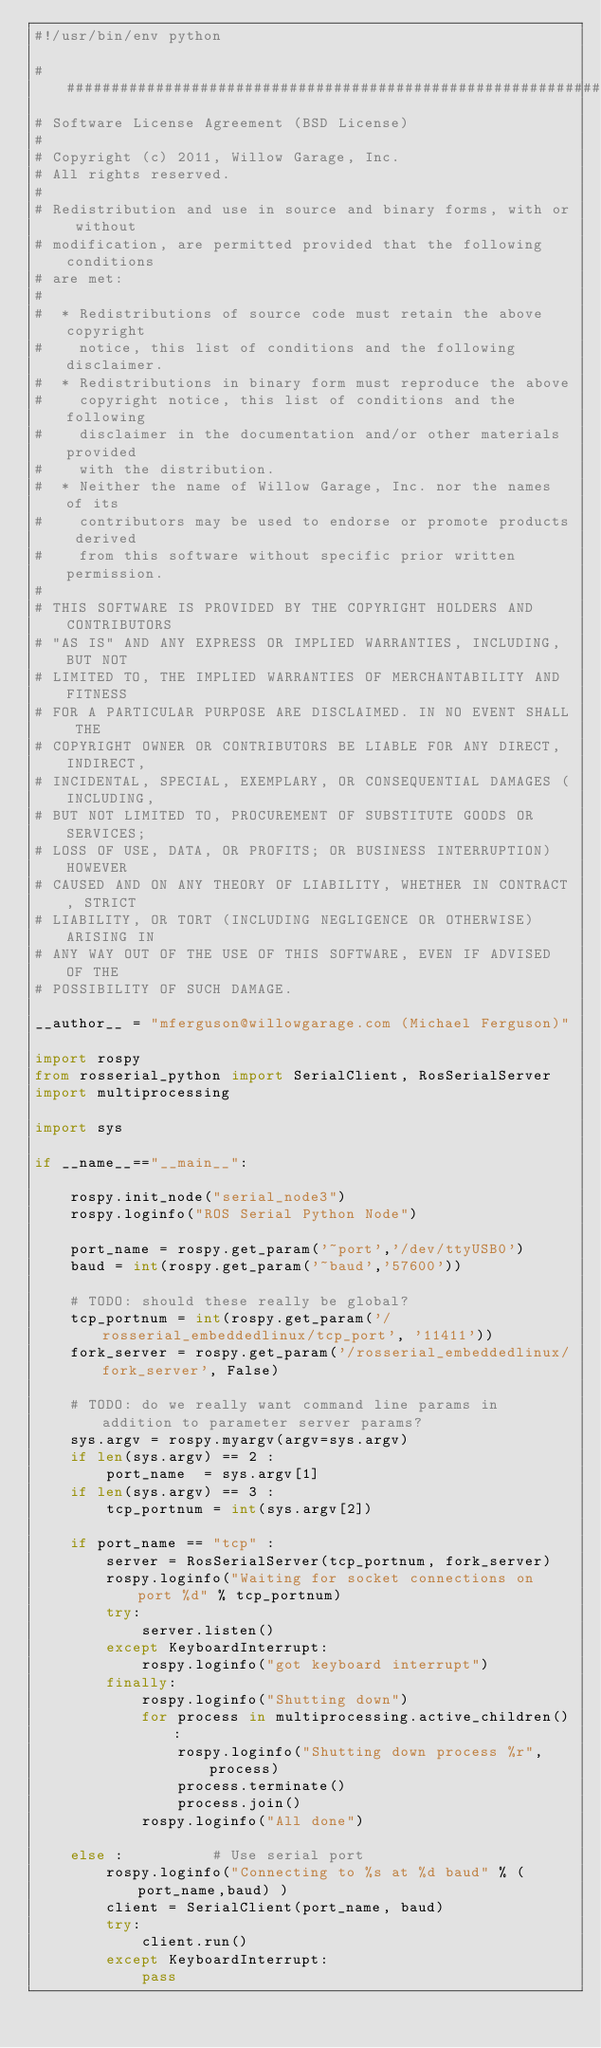<code> <loc_0><loc_0><loc_500><loc_500><_Python_>#!/usr/bin/env python

#####################################################################
# Software License Agreement (BSD License)
#
# Copyright (c) 2011, Willow Garage, Inc.
# All rights reserved.
#
# Redistribution and use in source and binary forms, with or without
# modification, are permitted provided that the following conditions
# are met:
#
#  * Redistributions of source code must retain the above copyright
#    notice, this list of conditions and the following disclaimer.
#  * Redistributions in binary form must reproduce the above
#    copyright notice, this list of conditions and the following
#    disclaimer in the documentation and/or other materials provided
#    with the distribution.
#  * Neither the name of Willow Garage, Inc. nor the names of its
#    contributors may be used to endorse or promote products derived
#    from this software without specific prior written permission.
#
# THIS SOFTWARE IS PROVIDED BY THE COPYRIGHT HOLDERS AND CONTRIBUTORS
# "AS IS" AND ANY EXPRESS OR IMPLIED WARRANTIES, INCLUDING, BUT NOT
# LIMITED TO, THE IMPLIED WARRANTIES OF MERCHANTABILITY AND FITNESS
# FOR A PARTICULAR PURPOSE ARE DISCLAIMED. IN NO EVENT SHALL THE
# COPYRIGHT OWNER OR CONTRIBUTORS BE LIABLE FOR ANY DIRECT, INDIRECT,
# INCIDENTAL, SPECIAL, EXEMPLARY, OR CONSEQUENTIAL DAMAGES (INCLUDING,
# BUT NOT LIMITED TO, PROCUREMENT OF SUBSTITUTE GOODS OR SERVICES;
# LOSS OF USE, DATA, OR PROFITS; OR BUSINESS INTERRUPTION) HOWEVER
# CAUSED AND ON ANY THEORY OF LIABILITY, WHETHER IN CONTRACT, STRICT
# LIABILITY, OR TORT (INCLUDING NEGLIGENCE OR OTHERWISE) ARISING IN
# ANY WAY OUT OF THE USE OF THIS SOFTWARE, EVEN IF ADVISED OF THE
# POSSIBILITY OF SUCH DAMAGE.

__author__ = "mferguson@willowgarage.com (Michael Ferguson)"

import rospy
from rosserial_python import SerialClient, RosSerialServer
import multiprocessing

import sys
   
if __name__=="__main__":

    rospy.init_node("serial_node3")
    rospy.loginfo("ROS Serial Python Node")

    port_name = rospy.get_param('~port','/dev/ttyUSB0')
    baud = int(rospy.get_param('~baud','57600'))

    # TODO: should these really be global?
    tcp_portnum = int(rospy.get_param('/rosserial_embeddedlinux/tcp_port', '11411'))
    fork_server = rospy.get_param('/rosserial_embeddedlinux/fork_server', False)

    # TODO: do we really want command line params in addition to parameter server params?
    sys.argv = rospy.myargv(argv=sys.argv)
    if len(sys.argv) == 2 :
        port_name  = sys.argv[1]
    if len(sys.argv) == 3 :
        tcp_portnum = int(sys.argv[2])
    
    if port_name == "tcp" :
        server = RosSerialServer(tcp_portnum, fork_server)
        rospy.loginfo("Waiting for socket connections on port %d" % tcp_portnum)
        try:
            server.listen()
        except KeyboardInterrupt:
            rospy.loginfo("got keyboard interrupt")
        finally:
            rospy.loginfo("Shutting down")
            for process in multiprocessing.active_children():
                rospy.loginfo("Shutting down process %r", process)
                process.terminate()
                process.join()
            rospy.loginfo("All done")

    else :          # Use serial port 
        rospy.loginfo("Connecting to %s at %d baud" % (port_name,baud) )
        client = SerialClient(port_name, baud)
        try:
            client.run()
        except KeyboardInterrupt:
            pass

</code> 